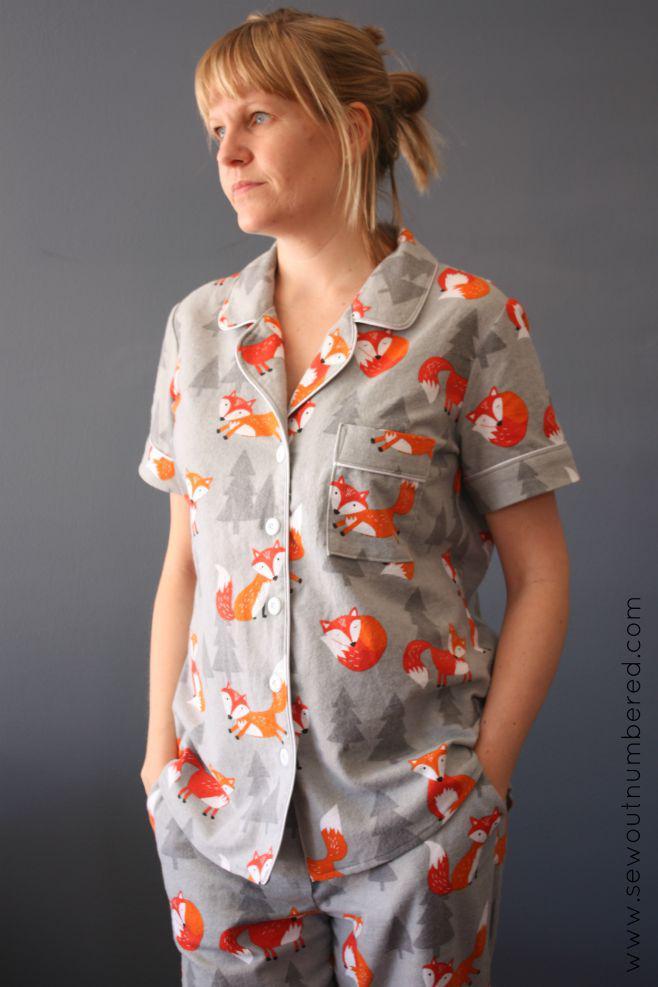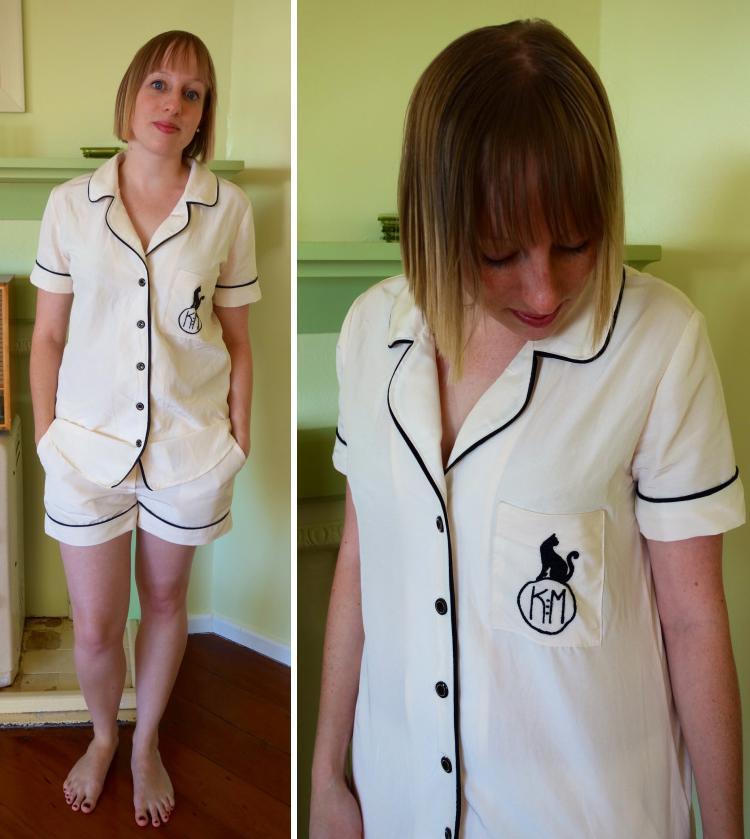The first image is the image on the left, the second image is the image on the right. Considering the images on both sides, is "One image has two ladies with one of the ladies wearing shorts." valid? Answer yes or no. Yes. 